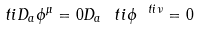Convert formula to latex. <formula><loc_0><loc_0><loc_500><loc_500>\ t i { D } _ { a } \phi ^ { \mu } = 0 D _ { a } \ t i { \phi } ^ { \ t i { \nu } } = 0</formula> 